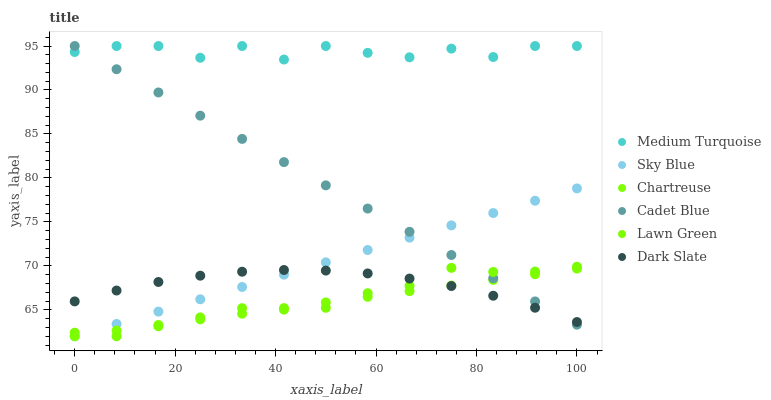Does Chartreuse have the minimum area under the curve?
Answer yes or no. Yes. Does Medium Turquoise have the maximum area under the curve?
Answer yes or no. Yes. Does Cadet Blue have the minimum area under the curve?
Answer yes or no. No. Does Cadet Blue have the maximum area under the curve?
Answer yes or no. No. Is Chartreuse the smoothest?
Answer yes or no. Yes. Is Medium Turquoise the roughest?
Answer yes or no. Yes. Is Cadet Blue the smoothest?
Answer yes or no. No. Is Cadet Blue the roughest?
Answer yes or no. No. Does Lawn Green have the lowest value?
Answer yes or no. Yes. Does Cadet Blue have the lowest value?
Answer yes or no. No. Does Medium Turquoise have the highest value?
Answer yes or no. Yes. Does Dark Slate have the highest value?
Answer yes or no. No. Is Dark Slate less than Medium Turquoise?
Answer yes or no. Yes. Is Medium Turquoise greater than Lawn Green?
Answer yes or no. Yes. Does Lawn Green intersect Chartreuse?
Answer yes or no. Yes. Is Lawn Green less than Chartreuse?
Answer yes or no. No. Is Lawn Green greater than Chartreuse?
Answer yes or no. No. Does Dark Slate intersect Medium Turquoise?
Answer yes or no. No. 